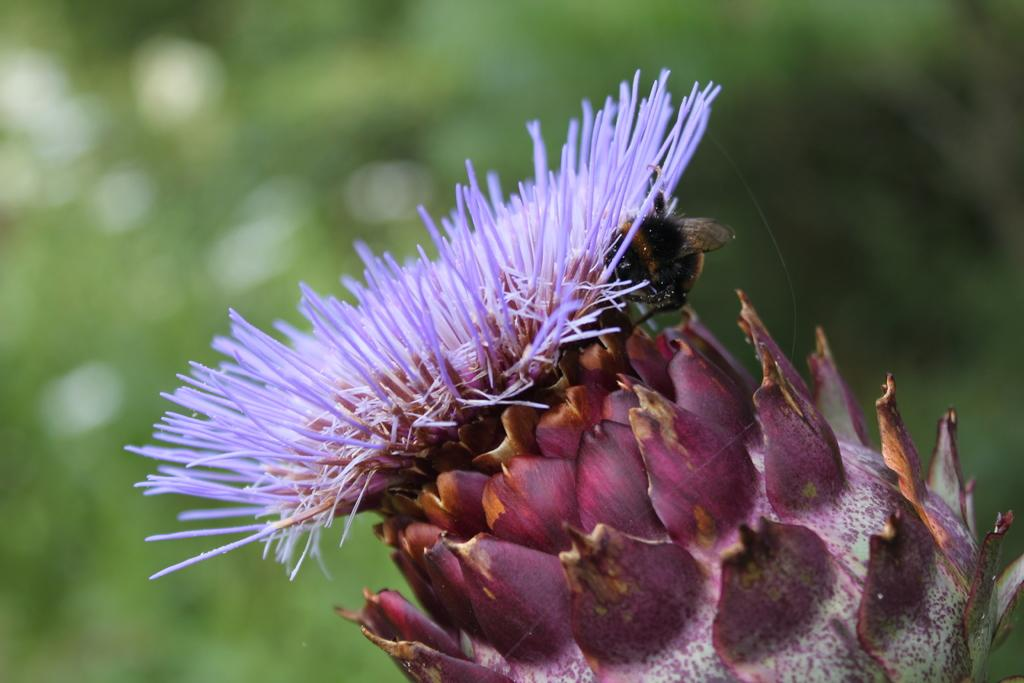What is the main subject of the image? The main subject of the image is a flower. What color is the flower? The flower is in violet color. What color are the flower's leaves? The flower's leaves are in pink color. Are there any other living organisms present in the image? Yes, there is a bee on the flower. How many grapes are hanging from the flower in the image? There are no grapes present in the image; it features a flower with a bee on it. What type of hands can be seen holding the flower in the image? There are no hands visible in the image; it only shows a flower with a bee on it. 